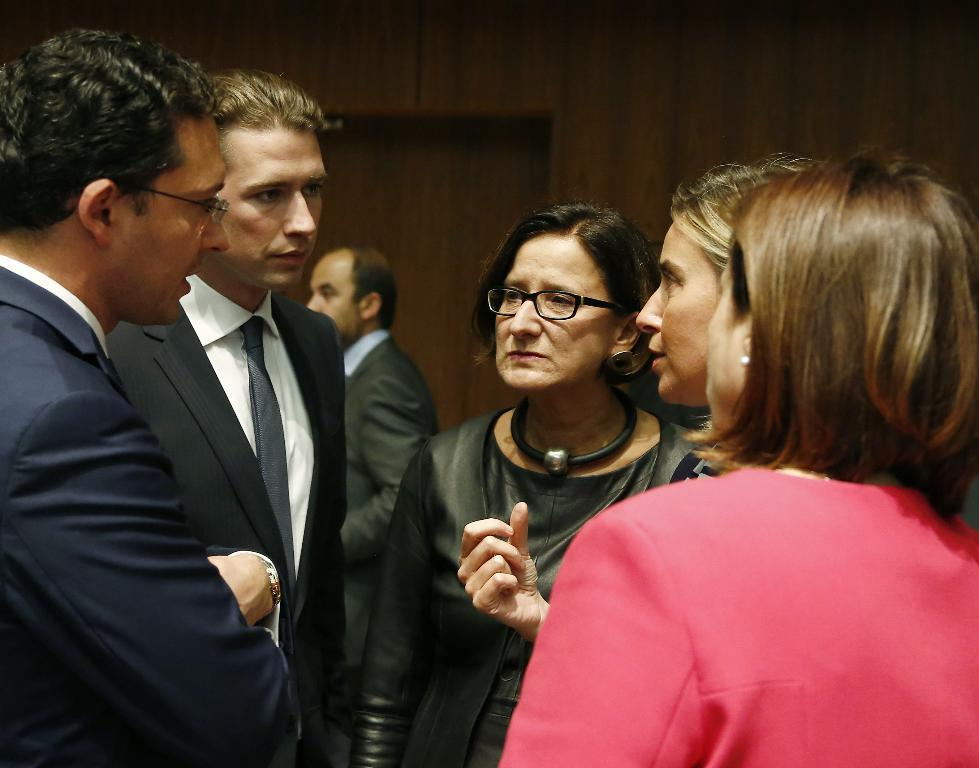What can be seen in the image? There are people standing in the image. Where are the people standing? The people are standing on the floor. What else is visible in the image besides the people? There is a wall visible in the image. How many jellyfish are swimming in the image? There are no jellyfish present in the image; it features people standing on the floor with a wall visible. 